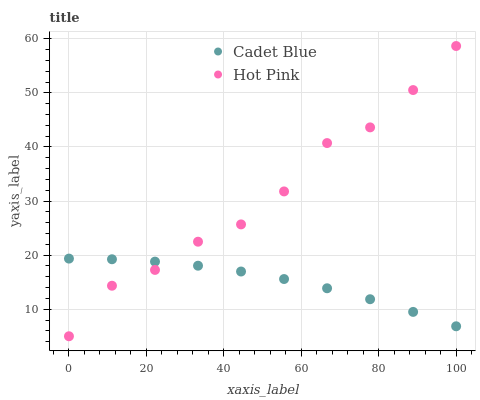Does Cadet Blue have the minimum area under the curve?
Answer yes or no. Yes. Does Hot Pink have the maximum area under the curve?
Answer yes or no. Yes. Does Hot Pink have the minimum area under the curve?
Answer yes or no. No. Is Cadet Blue the smoothest?
Answer yes or no. Yes. Is Hot Pink the roughest?
Answer yes or no. Yes. Is Hot Pink the smoothest?
Answer yes or no. No. Does Hot Pink have the lowest value?
Answer yes or no. Yes. Does Hot Pink have the highest value?
Answer yes or no. Yes. Does Cadet Blue intersect Hot Pink?
Answer yes or no. Yes. Is Cadet Blue less than Hot Pink?
Answer yes or no. No. Is Cadet Blue greater than Hot Pink?
Answer yes or no. No. 